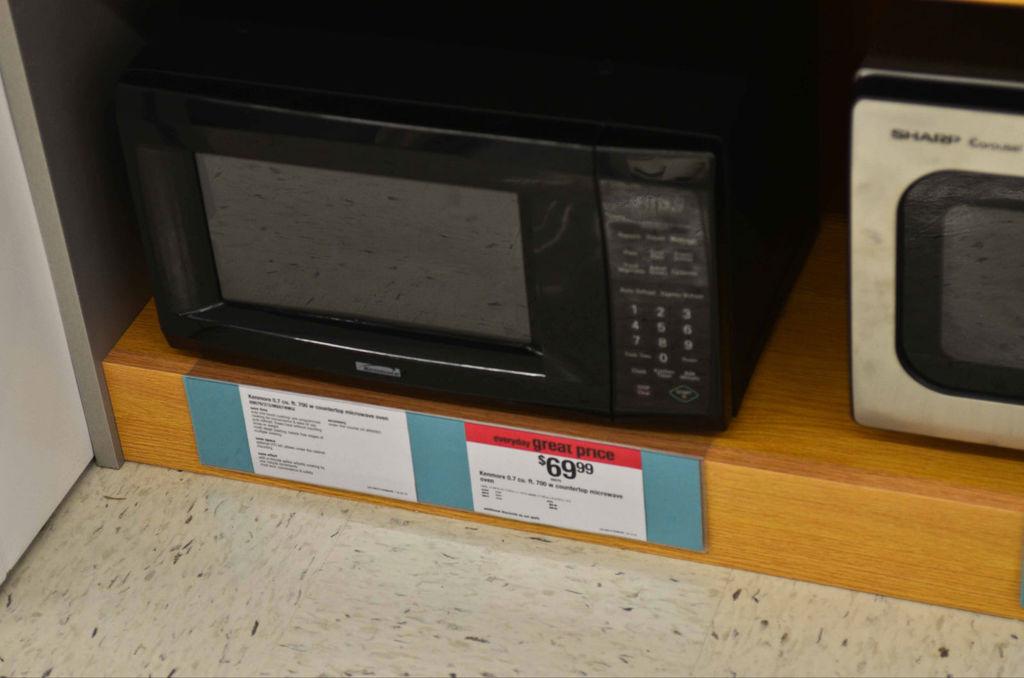Which microwave is 69 dollars?
Make the answer very short. Left. How much is the microwave?
Give a very brief answer. 69.99. 